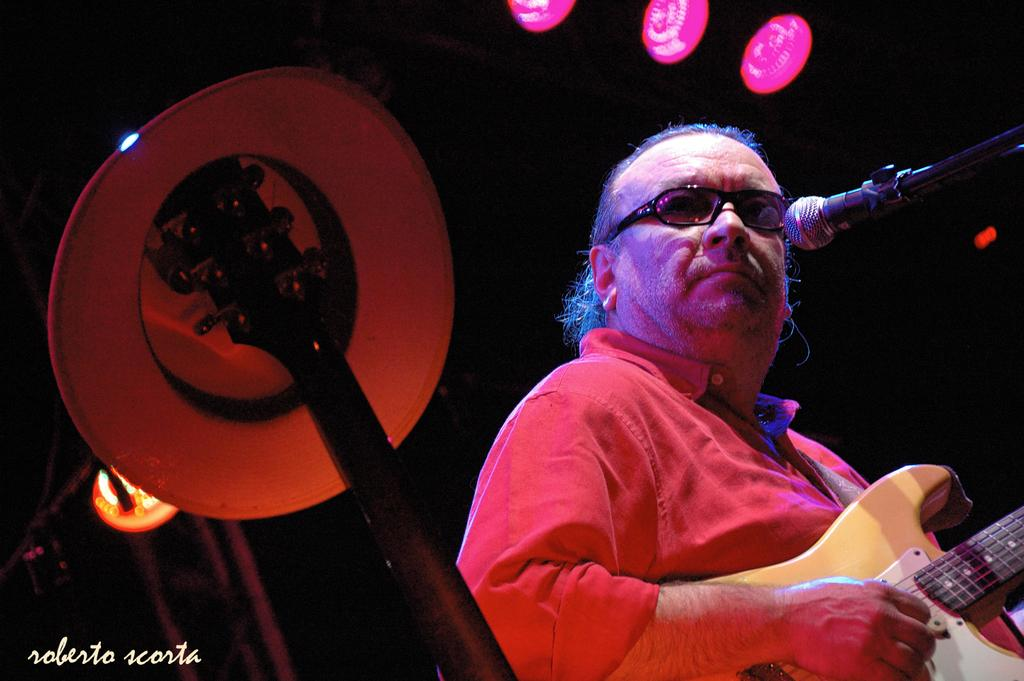What is placed on top of the guitar in the image? A hat is placed on the guitar. What is the person wearing in the image? The person is wearing a red shirt and goggles. What is the person holding in the image? The person is holding a guitar. What is the person doing with the guitar? The person is playing the guitar. What can be seen in front of the person? There is a mic stand in front of the person. What can be seen in the background of the image? There are lights visible in the image. What type of insect is crawling on the person's red shirt in the image? There is no insect visible on the person's red shirt in the image. What type of prison is the person playing the guitar in? The image does not depict a prison, and there is no indication that the person is playing the guitar in a prison setting. 